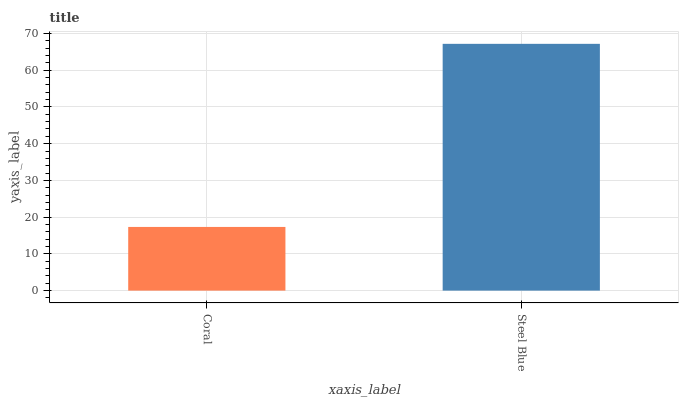Is Coral the minimum?
Answer yes or no. Yes. Is Steel Blue the maximum?
Answer yes or no. Yes. Is Steel Blue the minimum?
Answer yes or no. No. Is Steel Blue greater than Coral?
Answer yes or no. Yes. Is Coral less than Steel Blue?
Answer yes or no. Yes. Is Coral greater than Steel Blue?
Answer yes or no. No. Is Steel Blue less than Coral?
Answer yes or no. No. Is Steel Blue the high median?
Answer yes or no. Yes. Is Coral the low median?
Answer yes or no. Yes. Is Coral the high median?
Answer yes or no. No. Is Steel Blue the low median?
Answer yes or no. No. 